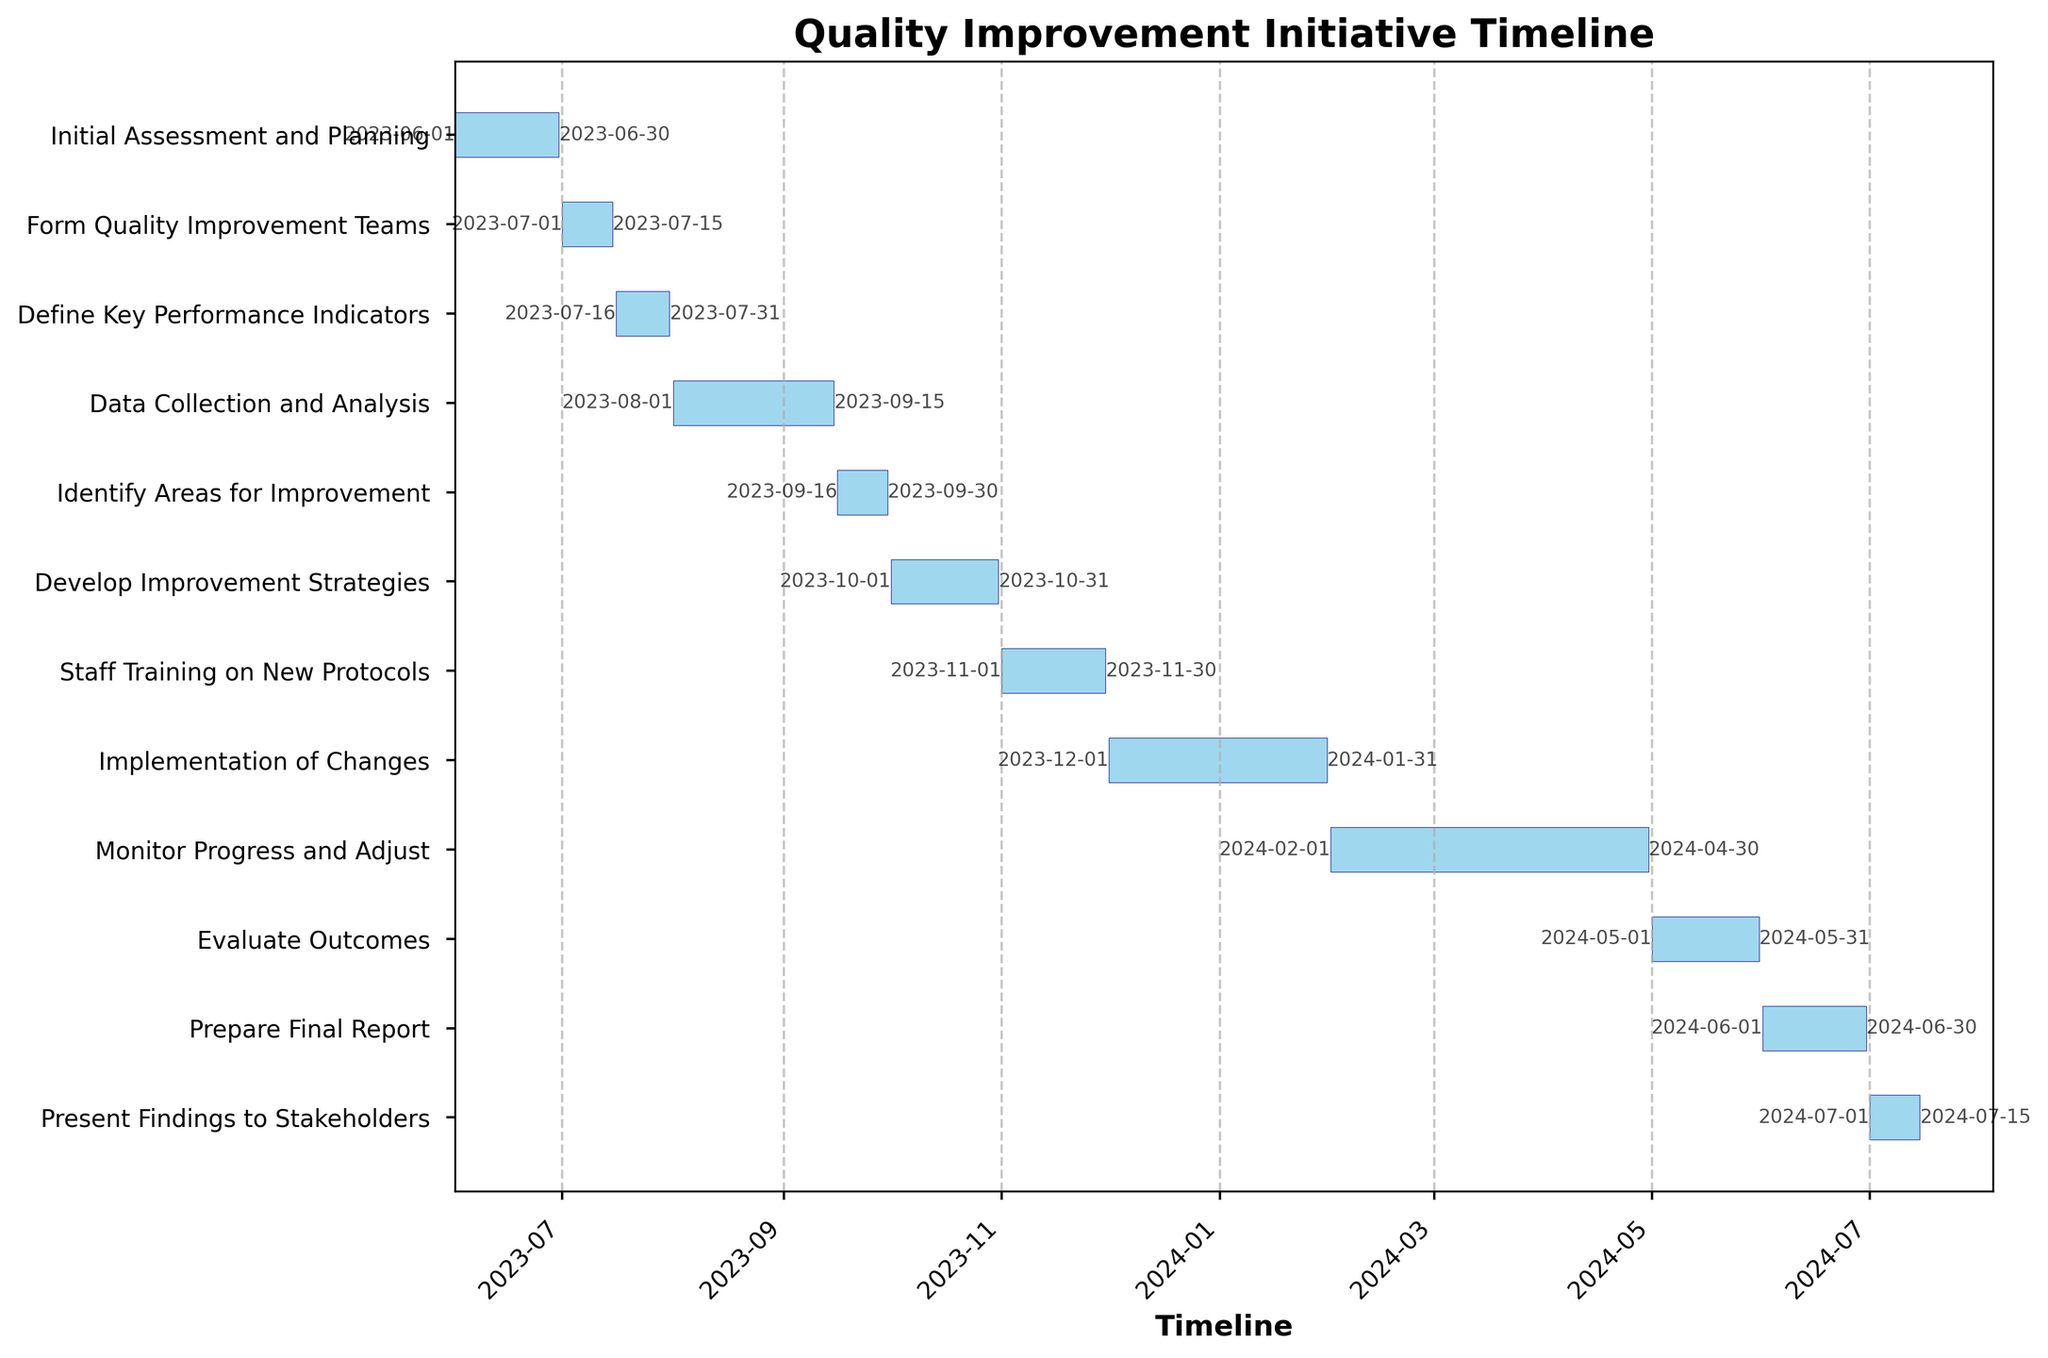What is the title of the chart? The title of the chart is a basic element located at the top of the figure, and it usually provides a brief description of the chart's content.
Answer: Quality Improvement Initiative Timeline Which task takes the longest period to complete? To identify the longest task duration, look at the horizontal bars and compare their lengths. The longest bar corresponds to the longest task duration.
Answer: Monitor Progress and Adjust When does the "Initial Assessment and Planning" task start and end? Refer to the left-hand text labels to find the "Initial Assessment and Planning" task, then trace horizontally to the start and end dates attached to that task.
Answer: 2023-06-01 to 2023-06-30 How many tasks are scheduled to start in 2023? Identify the tasks by their start dates and count how many fall within the year 2023.
Answer: 9 What is the combined duration of the "Define Key Performance Indicators" and "Data Collection and Analysis" tasks? Find the durations of both tasks (15 days for "Define Key Performance Indicators" and 46 days for "Data Collection and Analysis") and add them together.
Answer: 61 days Which task has the shortest duration, and what is it? Compare the durations of all tasks, identifying the shortest bar on the Gantt chart and noting the associated task.
Answer: Form Quality Improvement Teams (15 days) How many tasks overlap in the month of July 2023? Identify the tasks that have any part of their duration within July 2023 by examining their start and end dates, and count the number of such tasks.
Answer: 3 Is there any gap between the task "Develop Improvement Strategies" and "Staff Training on New Protocols"? Check the end date of "Develop Improvement Strategies" (2023-10-31) and the start date of "Staff Training on New Protocols" (2023-11-01) to see if there is any gap.
Answer: No How long does the "Implementation of Changes" task take? Check the start and end date of the "Implementation of Changes" task to calculate its total duration.
Answer: 62 days When does the "Present Findings to Stakeholders" task end? Find the task "Present Findings to Stakeholders" and note its end date from the associated label.
Answer: 2024-07-15 